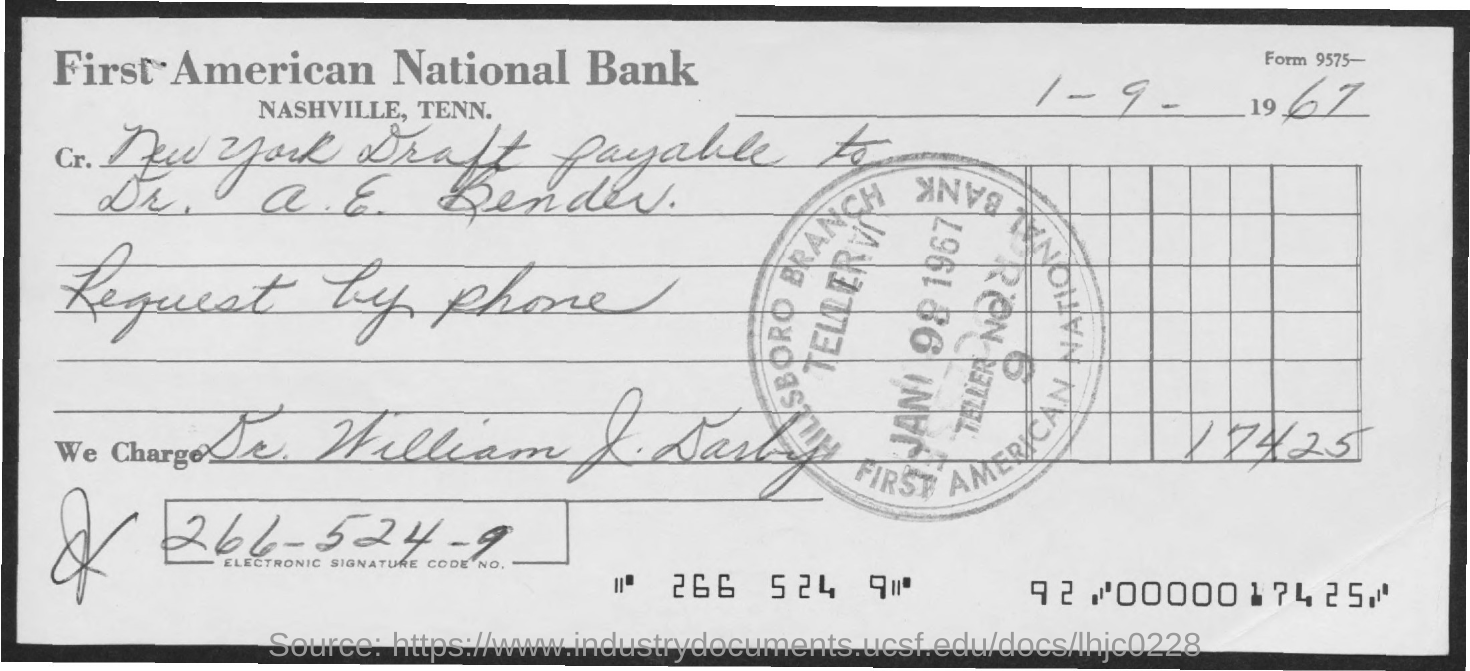Outline some significant characteristics in this image. The title of the document is "What is the title of the document? First American National Bank. The date mentioned in the document is 1 September 1967. The code number for electronic signatures is 266-524-9... 